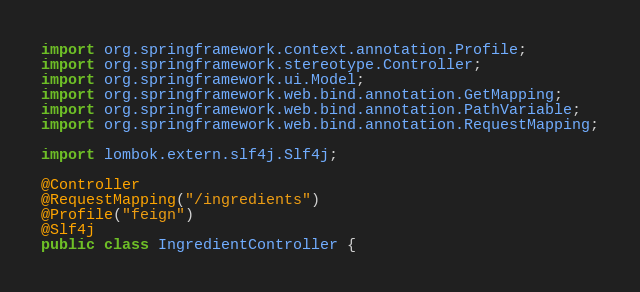<code> <loc_0><loc_0><loc_500><loc_500><_Java_>
import org.springframework.context.annotation.Profile;
import org.springframework.stereotype.Controller;
import org.springframework.ui.Model;
import org.springframework.web.bind.annotation.GetMapping;
import org.springframework.web.bind.annotation.PathVariable;
import org.springframework.web.bind.annotation.RequestMapping;

import lombok.extern.slf4j.Slf4j;

@Controller
@RequestMapping("/ingredients")
@Profile("feign")
@Slf4j
public class IngredientController {
</code> 